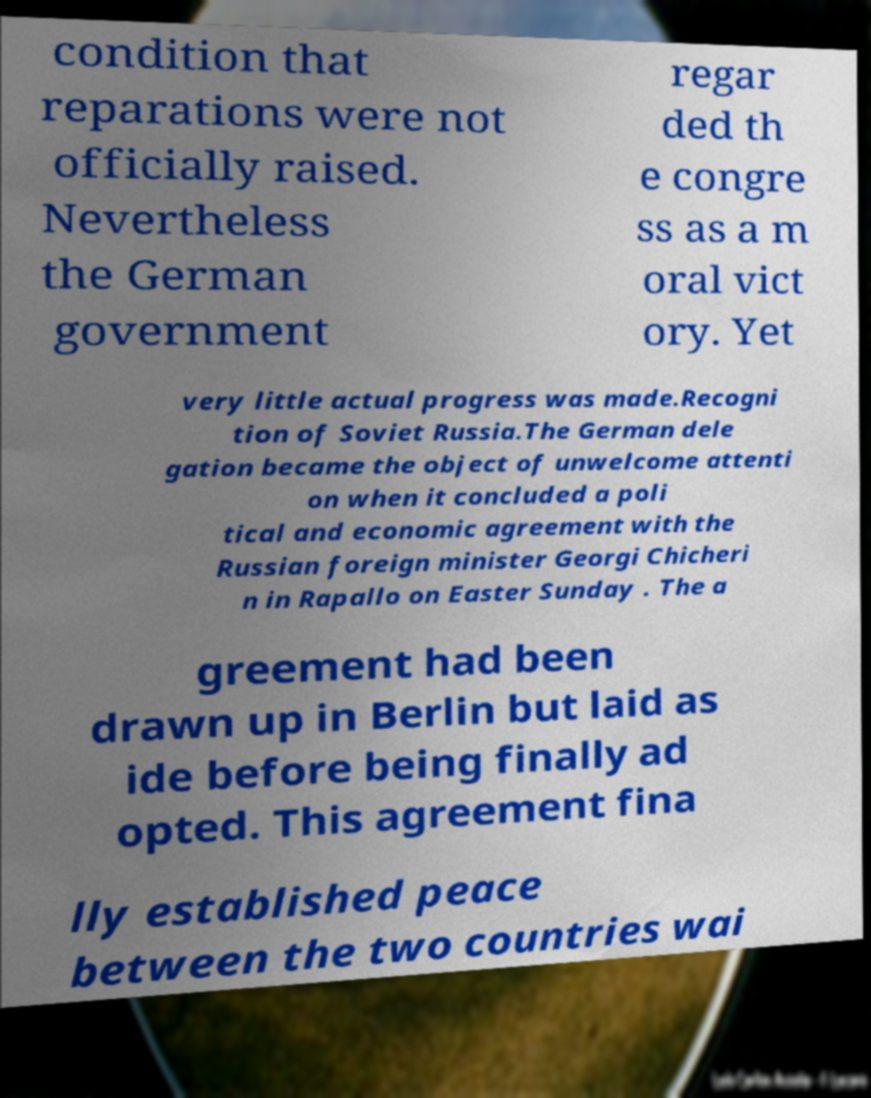Could you assist in decoding the text presented in this image and type it out clearly? condition that reparations were not officially raised. Nevertheless the German government regar ded th e congre ss as a m oral vict ory. Yet very little actual progress was made.Recogni tion of Soviet Russia.The German dele gation became the object of unwelcome attenti on when it concluded a poli tical and economic agreement with the Russian foreign minister Georgi Chicheri n in Rapallo on Easter Sunday . The a greement had been drawn up in Berlin but laid as ide before being finally ad opted. This agreement fina lly established peace between the two countries wai 